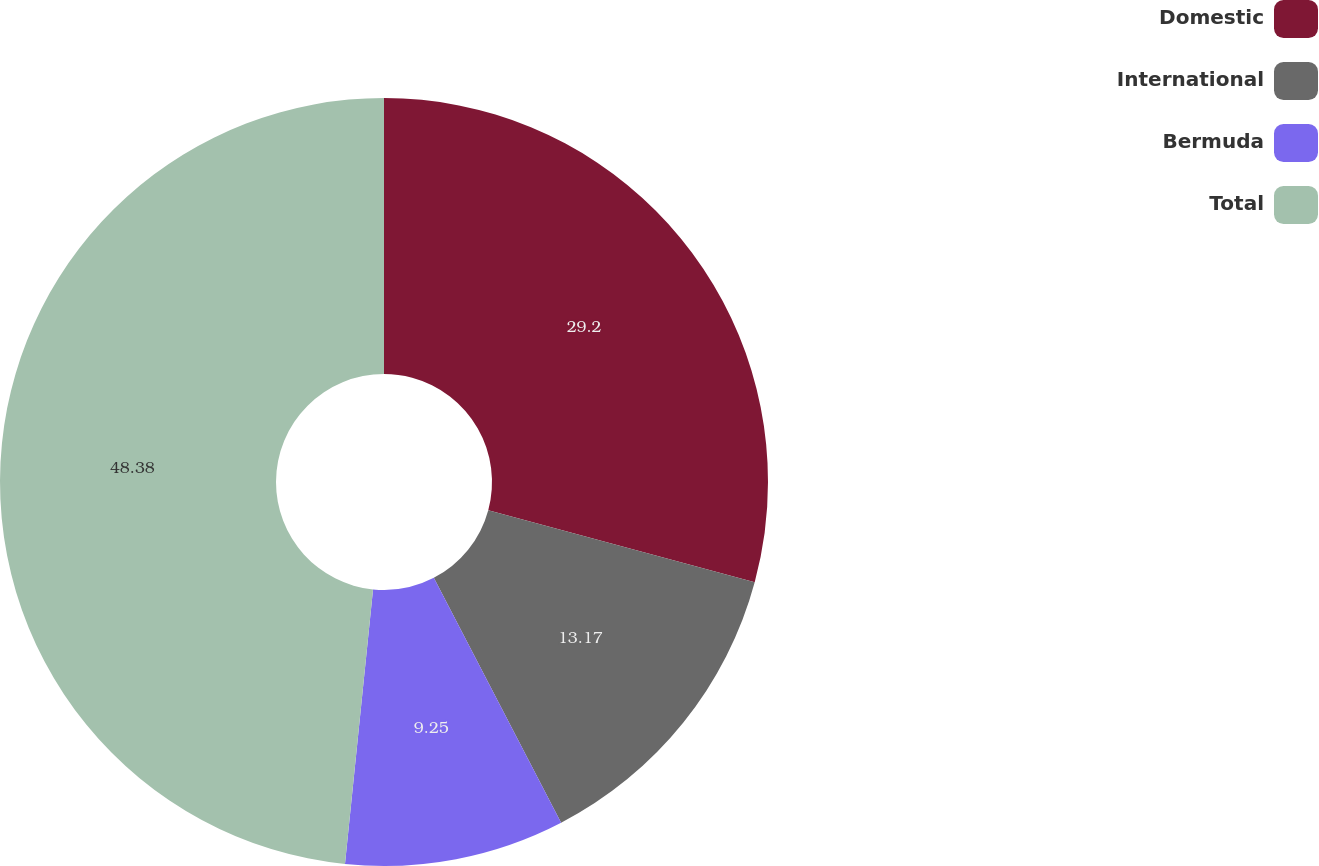Convert chart to OTSL. <chart><loc_0><loc_0><loc_500><loc_500><pie_chart><fcel>Domestic<fcel>International<fcel>Bermuda<fcel>Total<nl><fcel>29.2%<fcel>13.17%<fcel>9.25%<fcel>48.38%<nl></chart> 